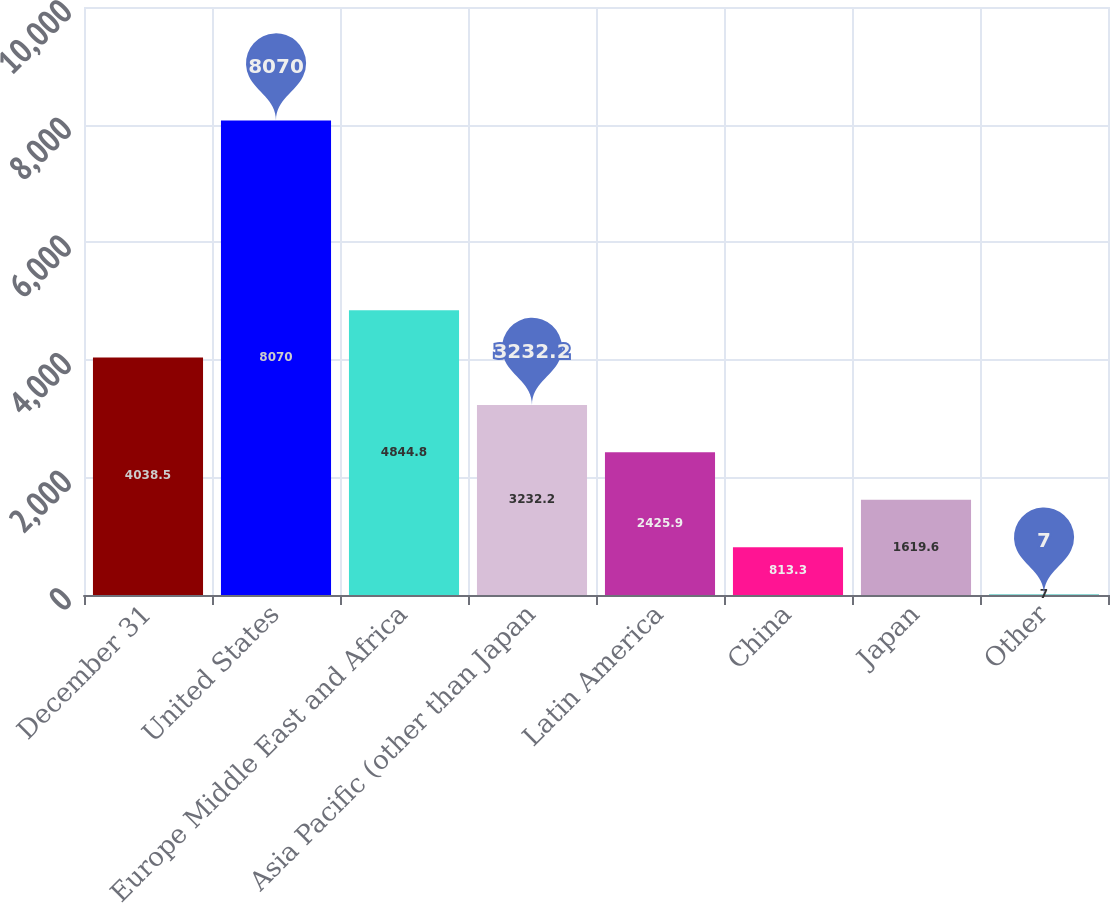Convert chart to OTSL. <chart><loc_0><loc_0><loc_500><loc_500><bar_chart><fcel>December 31<fcel>United States<fcel>Europe Middle East and Africa<fcel>Asia Pacific (other than Japan<fcel>Latin America<fcel>China<fcel>Japan<fcel>Other<nl><fcel>4038.5<fcel>8070<fcel>4844.8<fcel>3232.2<fcel>2425.9<fcel>813.3<fcel>1619.6<fcel>7<nl></chart> 